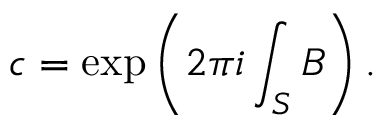Convert formula to latex. <formula><loc_0><loc_0><loc_500><loc_500>c = \exp \left ( 2 \pi i \int _ { S } B \right ) .</formula> 